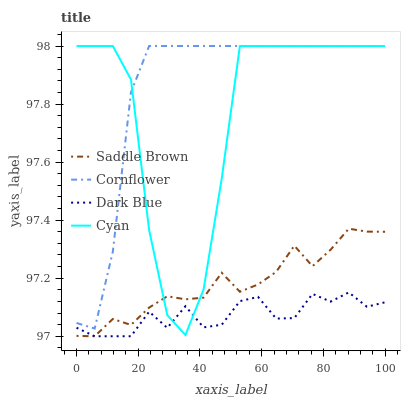Does Dark Blue have the minimum area under the curve?
Answer yes or no. Yes. Does Cornflower have the maximum area under the curve?
Answer yes or no. Yes. Does Cyan have the minimum area under the curve?
Answer yes or no. No. Does Cyan have the maximum area under the curve?
Answer yes or no. No. Is Saddle Brown the smoothest?
Answer yes or no. Yes. Is Cyan the roughest?
Answer yes or no. Yes. Is Cyan the smoothest?
Answer yes or no. No. Is Saddle Brown the roughest?
Answer yes or no. No. Does Saddle Brown have the lowest value?
Answer yes or no. Yes. Does Cyan have the lowest value?
Answer yes or no. No. Does Cyan have the highest value?
Answer yes or no. Yes. Does Saddle Brown have the highest value?
Answer yes or no. No. Is Dark Blue less than Cornflower?
Answer yes or no. Yes. Is Cornflower greater than Dark Blue?
Answer yes or no. Yes. Does Saddle Brown intersect Cyan?
Answer yes or no. Yes. Is Saddle Brown less than Cyan?
Answer yes or no. No. Is Saddle Brown greater than Cyan?
Answer yes or no. No. Does Dark Blue intersect Cornflower?
Answer yes or no. No. 